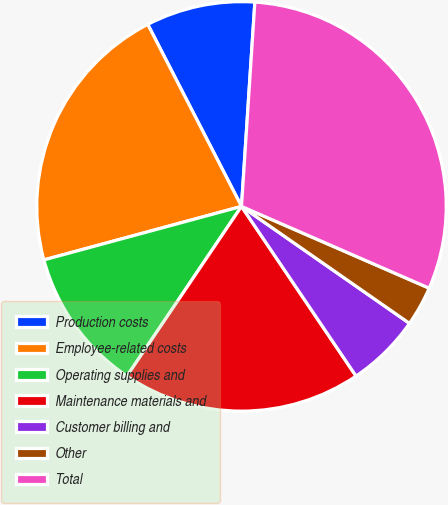Convert chart to OTSL. <chart><loc_0><loc_0><loc_500><loc_500><pie_chart><fcel>Production costs<fcel>Employee-related costs<fcel>Operating supplies and<fcel>Maintenance materials and<fcel>Customer billing and<fcel>Other<fcel>Total<nl><fcel>8.61%<fcel>21.64%<fcel>11.34%<fcel>18.9%<fcel>5.87%<fcel>3.14%<fcel>30.5%<nl></chart> 